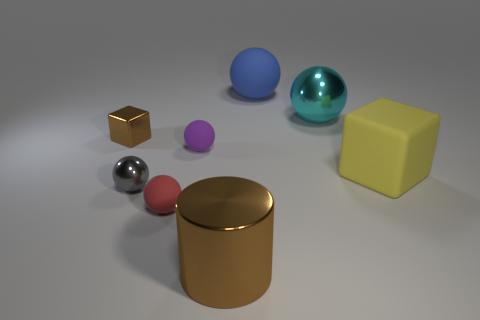Are there any yellow spheres made of the same material as the big brown object?
Your answer should be compact. No. The brown thing that is on the right side of the brown metallic object that is behind the red rubber thing is made of what material?
Offer a very short reply. Metal. Are there the same number of tiny metallic spheres in front of the big blue ball and small shiny things on the left side of the small brown metal object?
Make the answer very short. No. Do the small brown shiny object and the small purple matte object have the same shape?
Make the answer very short. No. What is the large thing that is to the right of the blue rubber ball and in front of the cyan thing made of?
Offer a terse response. Rubber. What number of small metal things are the same shape as the big yellow rubber thing?
Give a very brief answer. 1. How big is the block on the right side of the brown metal thing behind the brown shiny object in front of the red ball?
Provide a succinct answer. Large. Are there more big cyan shiny objects in front of the large yellow matte block than gray metal balls?
Provide a succinct answer. No. Is there a big yellow rubber cube?
Provide a short and direct response. Yes. How many yellow things have the same size as the blue matte thing?
Your response must be concise. 1. 